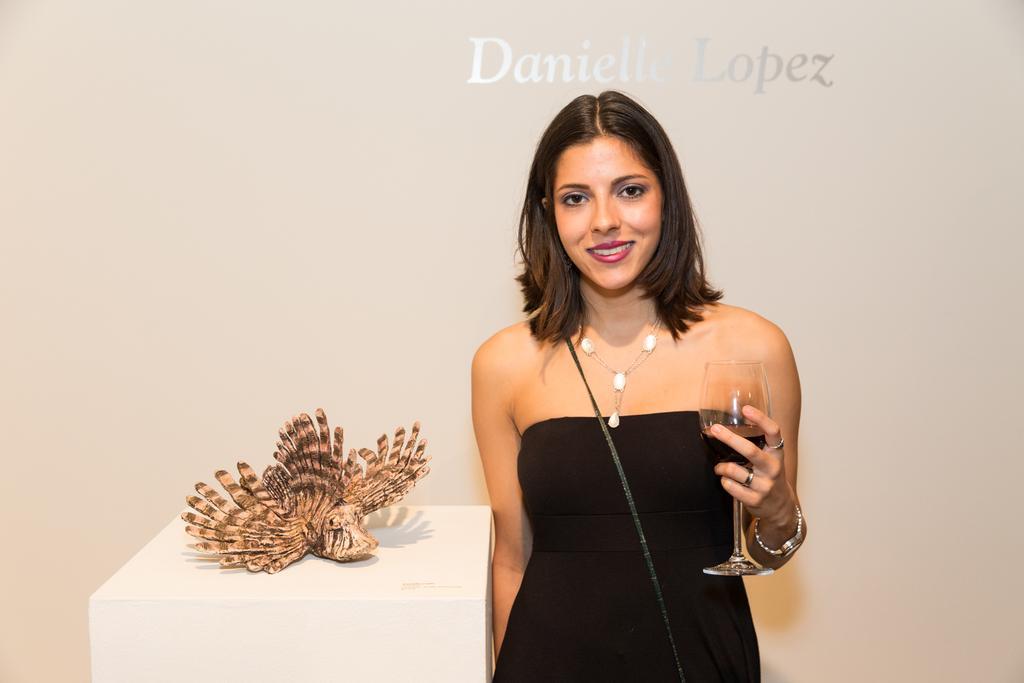How would you summarize this image in a sentence or two? On the right a woman is standing with a wine glass in her hand she is smiling. 